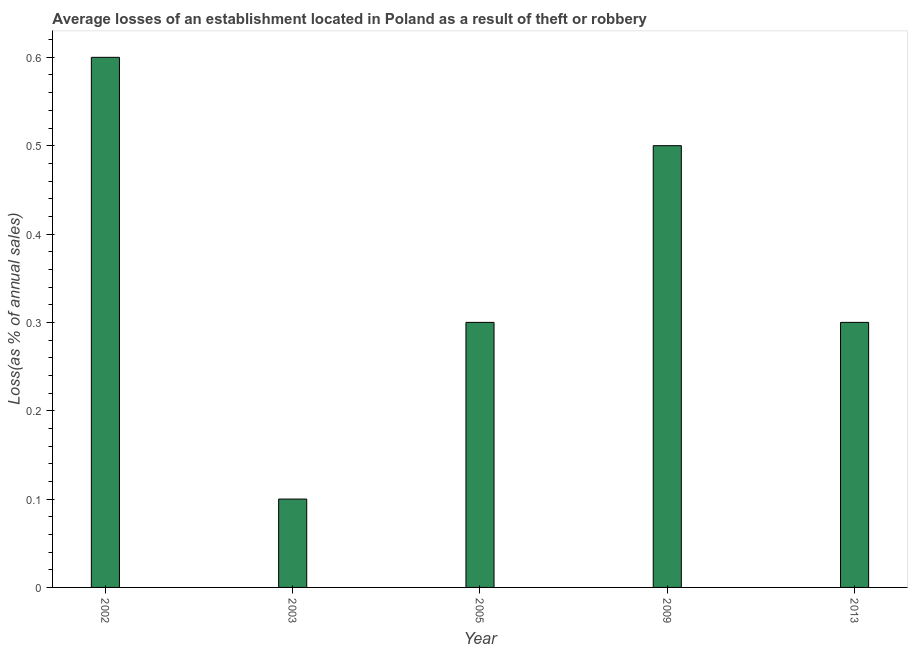Does the graph contain any zero values?
Make the answer very short. No. What is the title of the graph?
Make the answer very short. Average losses of an establishment located in Poland as a result of theft or robbery. What is the label or title of the X-axis?
Your answer should be very brief. Year. What is the label or title of the Y-axis?
Your response must be concise. Loss(as % of annual sales). What is the losses due to theft in 2005?
Provide a short and direct response. 0.3. Across all years, what is the maximum losses due to theft?
Make the answer very short. 0.6. Across all years, what is the minimum losses due to theft?
Offer a very short reply. 0.1. In which year was the losses due to theft maximum?
Ensure brevity in your answer.  2002. What is the sum of the losses due to theft?
Your response must be concise. 1.8. What is the average losses due to theft per year?
Your answer should be very brief. 0.36. In how many years, is the losses due to theft greater than 0.58 %?
Offer a terse response. 1. Is the losses due to theft in 2003 less than that in 2013?
Keep it short and to the point. Yes. What is the difference between the highest and the second highest losses due to theft?
Give a very brief answer. 0.1. Is the sum of the losses due to theft in 2009 and 2013 greater than the maximum losses due to theft across all years?
Keep it short and to the point. Yes. What is the difference between the highest and the lowest losses due to theft?
Your response must be concise. 0.5. In how many years, is the losses due to theft greater than the average losses due to theft taken over all years?
Ensure brevity in your answer.  2. How many bars are there?
Your answer should be compact. 5. What is the difference between two consecutive major ticks on the Y-axis?
Give a very brief answer. 0.1. Are the values on the major ticks of Y-axis written in scientific E-notation?
Offer a terse response. No. What is the Loss(as % of annual sales) of 2002?
Offer a terse response. 0.6. What is the Loss(as % of annual sales) in 2003?
Provide a short and direct response. 0.1. What is the Loss(as % of annual sales) of 2005?
Your answer should be compact. 0.3. What is the Loss(as % of annual sales) in 2009?
Give a very brief answer. 0.5. What is the difference between the Loss(as % of annual sales) in 2002 and 2003?
Make the answer very short. 0.5. What is the difference between the Loss(as % of annual sales) in 2002 and 2005?
Offer a very short reply. 0.3. What is the difference between the Loss(as % of annual sales) in 2002 and 2009?
Offer a very short reply. 0.1. What is the difference between the Loss(as % of annual sales) in 2002 and 2013?
Keep it short and to the point. 0.3. What is the difference between the Loss(as % of annual sales) in 2003 and 2009?
Keep it short and to the point. -0.4. What is the difference between the Loss(as % of annual sales) in 2003 and 2013?
Provide a succinct answer. -0.2. What is the difference between the Loss(as % of annual sales) in 2005 and 2013?
Offer a terse response. 0. What is the difference between the Loss(as % of annual sales) in 2009 and 2013?
Provide a short and direct response. 0.2. What is the ratio of the Loss(as % of annual sales) in 2003 to that in 2005?
Provide a succinct answer. 0.33. What is the ratio of the Loss(as % of annual sales) in 2003 to that in 2009?
Offer a terse response. 0.2. What is the ratio of the Loss(as % of annual sales) in 2003 to that in 2013?
Provide a succinct answer. 0.33. What is the ratio of the Loss(as % of annual sales) in 2009 to that in 2013?
Provide a succinct answer. 1.67. 